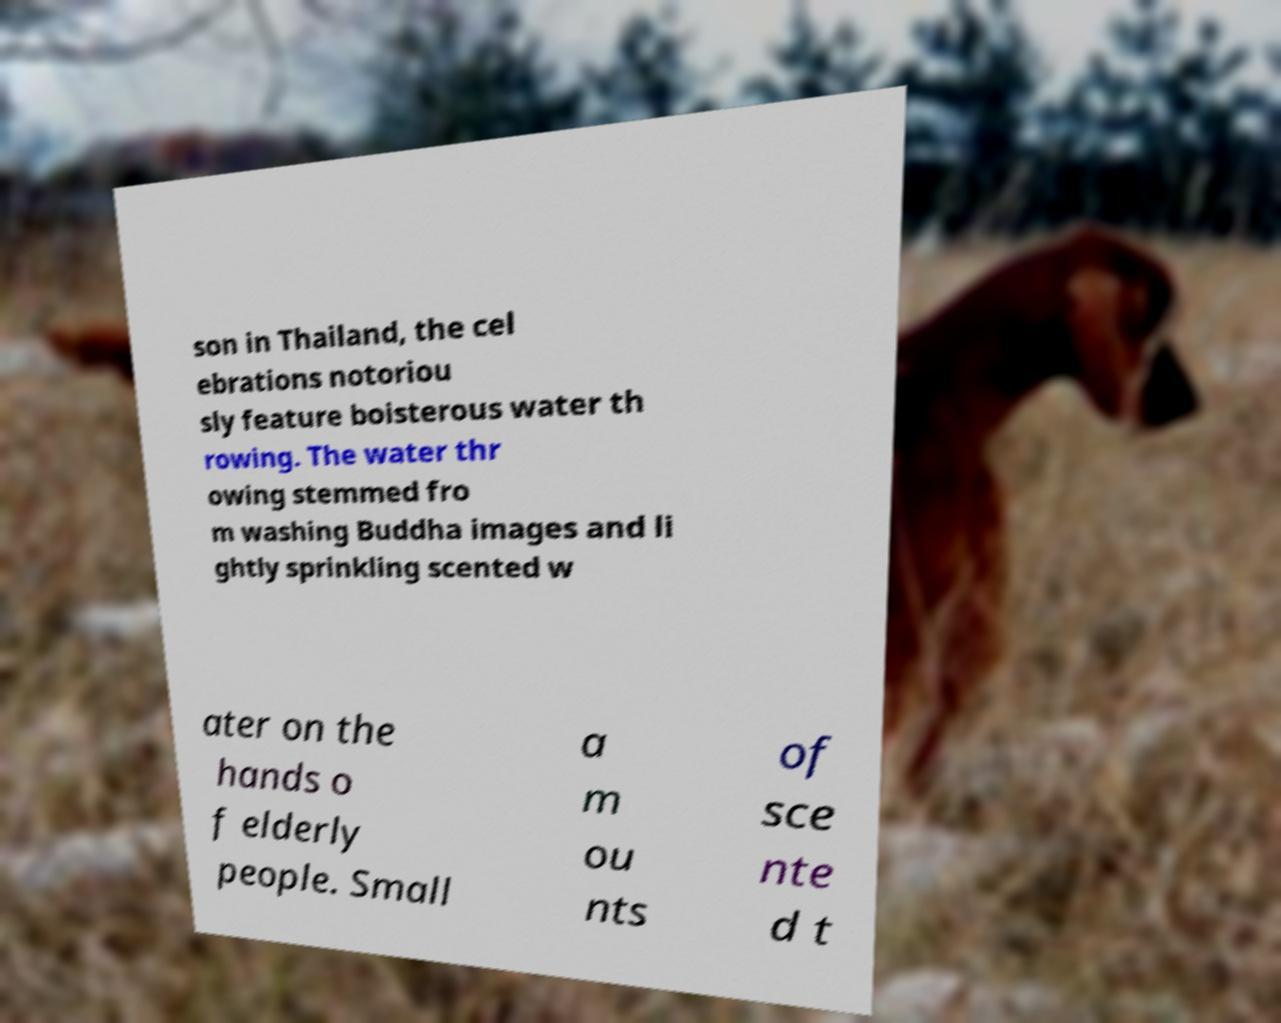Can you read and provide the text displayed in the image?This photo seems to have some interesting text. Can you extract and type it out for me? son in Thailand, the cel ebrations notoriou sly feature boisterous water th rowing. The water thr owing stemmed fro m washing Buddha images and li ghtly sprinkling scented w ater on the hands o f elderly people. Small a m ou nts of sce nte d t 